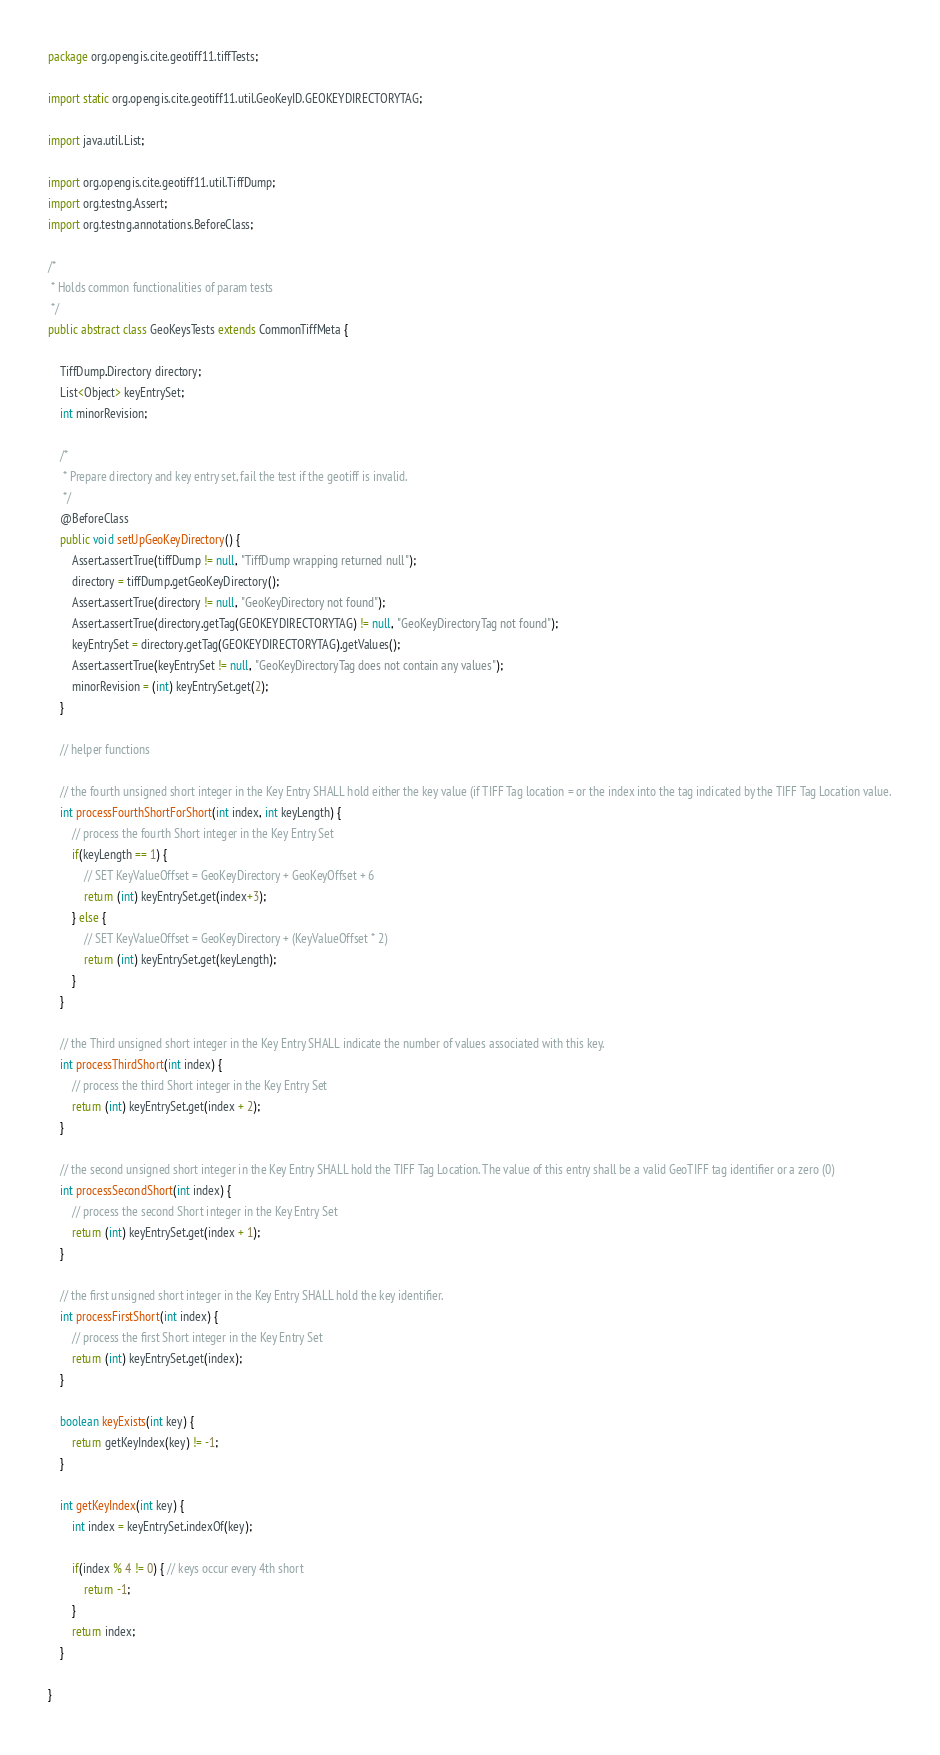Convert code to text. <code><loc_0><loc_0><loc_500><loc_500><_Java_>package org.opengis.cite.geotiff11.tiffTests;

import static org.opengis.cite.geotiff11.util.GeoKeyID.GEOKEYDIRECTORYTAG;

import java.util.List;

import org.opengis.cite.geotiff11.util.TiffDump;
import org.testng.Assert;
import org.testng.annotations.BeforeClass;

/*
 * Holds common functionalities of param tests
 */
public abstract class GeoKeysTests extends CommonTiffMeta {

	TiffDump.Directory directory;
	List<Object> keyEntrySet;
	int minorRevision;
	
	/*
	 * Prepare directory and key entry set, fail the test if the geotiff is invalid.
	 */
	@BeforeClass
	public void setUpGeoKeyDirectory() {
		Assert.assertTrue(tiffDump != null, "TiffDump wrapping returned null");
		directory = tiffDump.getGeoKeyDirectory();
		Assert.assertTrue(directory != null, "GeoKeyDirectory not found");
		Assert.assertTrue(directory.getTag(GEOKEYDIRECTORYTAG) != null, "GeoKeyDirectoryTag not found");
		keyEntrySet = directory.getTag(GEOKEYDIRECTORYTAG).getValues();	
		Assert.assertTrue(keyEntrySet != null, "GeoKeyDirectoryTag does not contain any values");
		minorRevision = (int) keyEntrySet.get(2);
	}
	
	// helper functions
	
	// the fourth unsigned short integer in the Key Entry SHALL hold either the key value (if TIFF Tag location = or the index into the tag indicated by the TIFF Tag Location value.
	int processFourthShortForShort(int index, int keyLength) {
		// process the fourth Short integer in the Key Entry Set
		if(keyLength == 1) {
			// SET KeyValueOffset = GeoKeyDirectory + GeoKeyOffset + 6
			return (int) keyEntrySet.get(index+3);
		} else {
			// SET KeyValueOffset = GeoKeyDirectory + (KeyValueOffset * 2)
			return (int) keyEntrySet.get(keyLength);
		}
	}
	
	// the Third unsigned short integer in the Key Entry SHALL indicate the number of values associated with this key.
	int processThirdShort(int index) {
		// process the third Short integer in the Key Entry Set
		return (int) keyEntrySet.get(index + 2);
	}
	
	// the second unsigned short integer in the Key Entry SHALL hold the TIFF Tag Location. The value of this entry shall be a valid GeoTIFF tag identifier or a zero (0)
	int processSecondShort(int index) {
		// process the second Short integer in the Key Entry Set
		return (int) keyEntrySet.get(index + 1);
	}
	
	// the first unsigned short integer in the Key Entry SHALL hold the key identifier.
	int processFirstShort(int index) {
		// process the first Short integer in the Key Entry Set
		return (int) keyEntrySet.get(index);
	}
	
	boolean keyExists(int key) {
		return getKeyIndex(key) != -1;
	}
	
	int getKeyIndex(int key) {
		int index = keyEntrySet.indexOf(key);
		
		if(index % 4 != 0) { // keys occur every 4th short
			return -1;
		}
		return index;
	}
	
}
</code> 